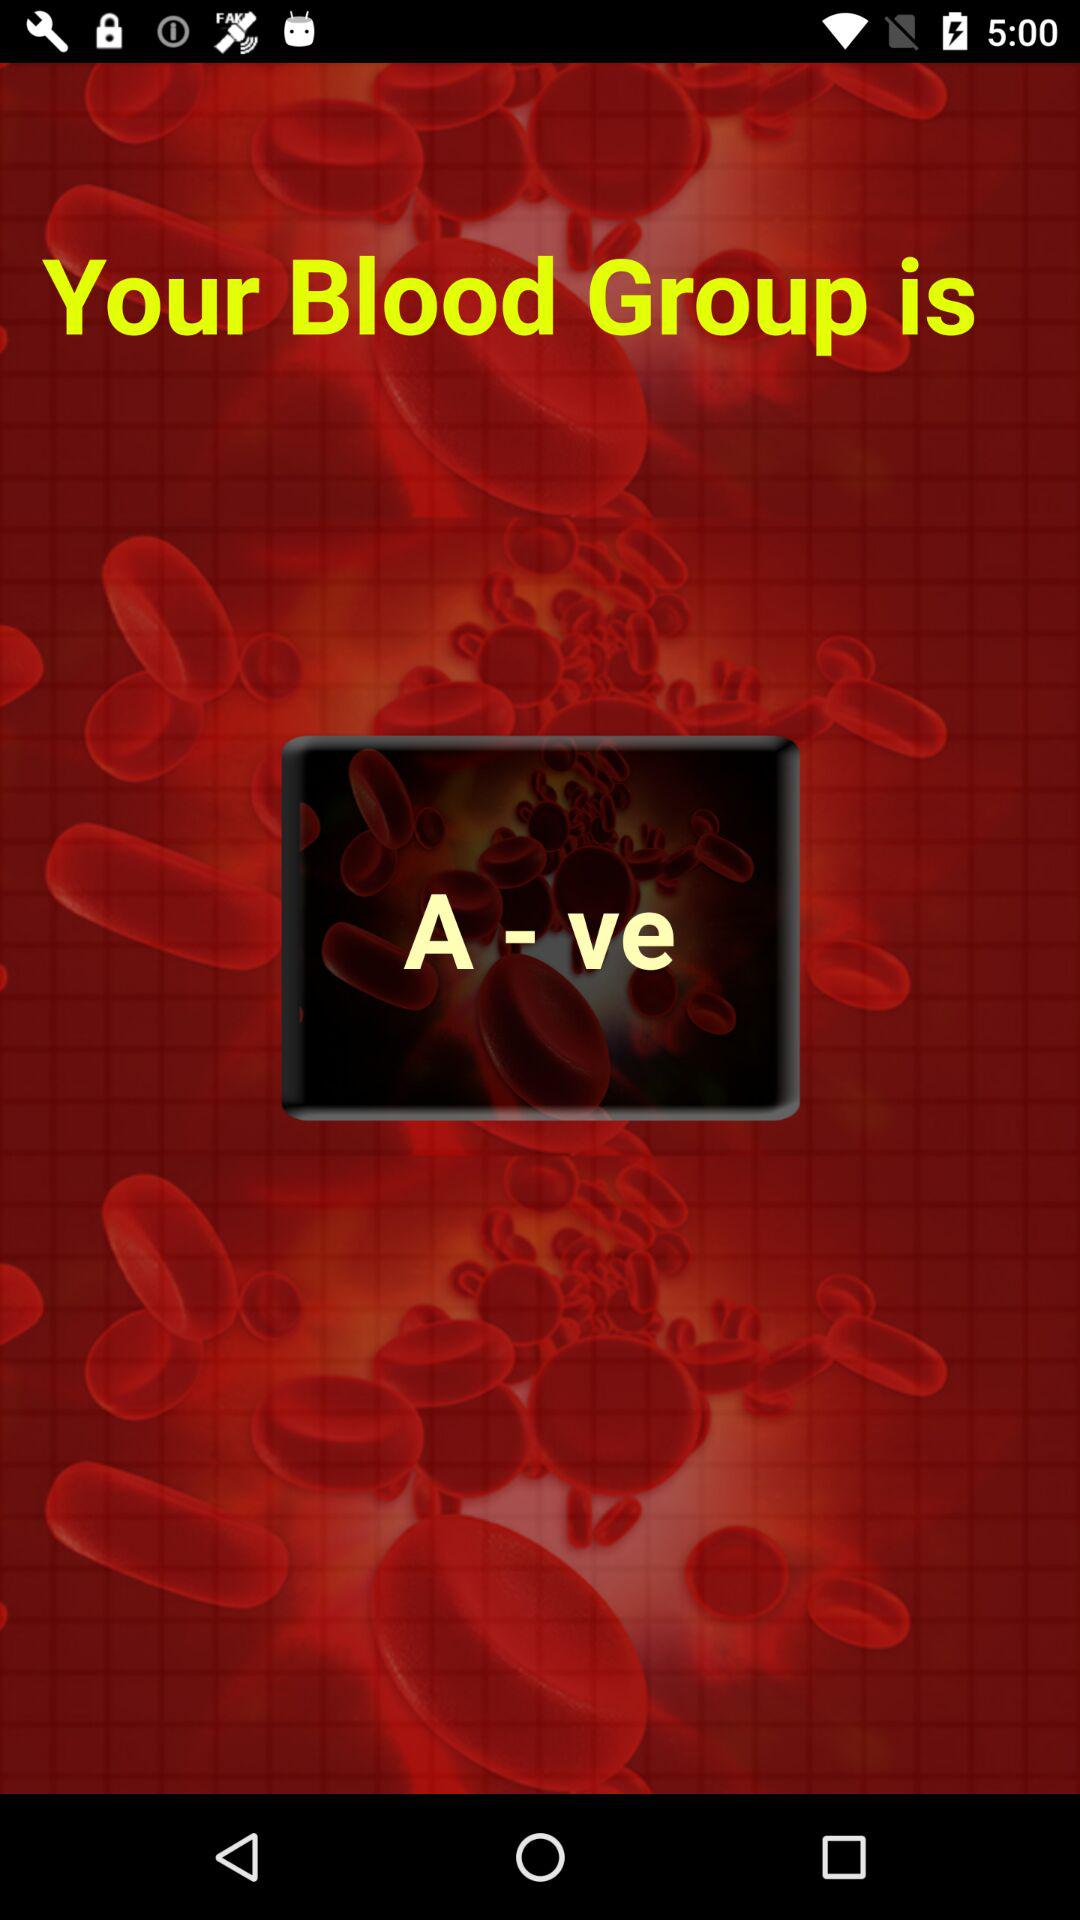What is the mentioned blood group? The mentioned blood group is A-ve. 